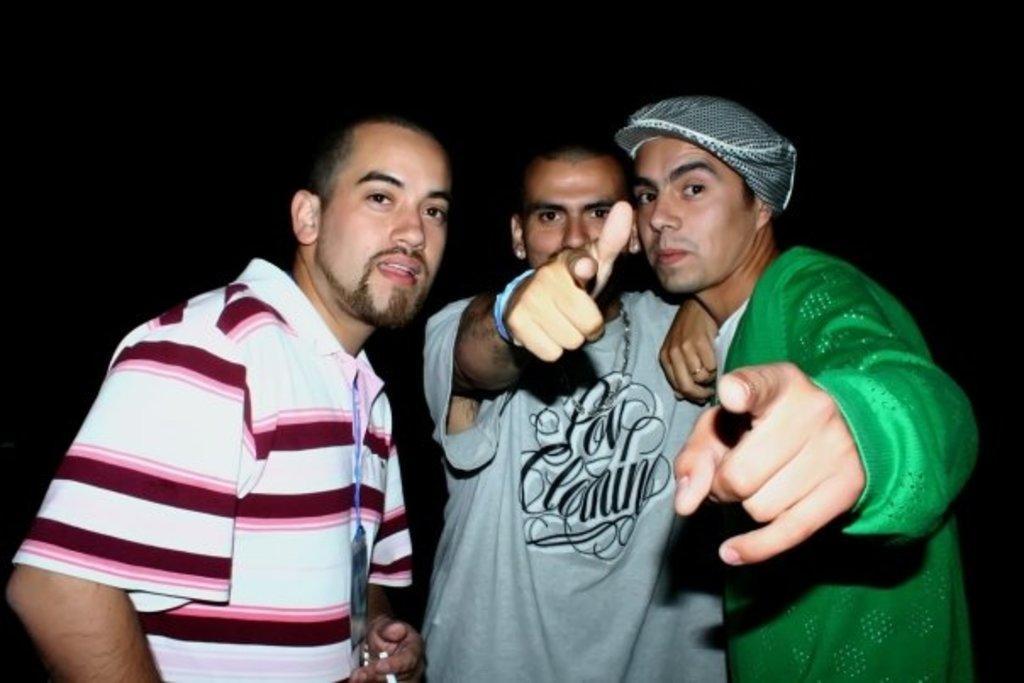In one or two sentences, can you explain what this image depicts? There are three men standing. This man wore a cap. The background looks dark. 